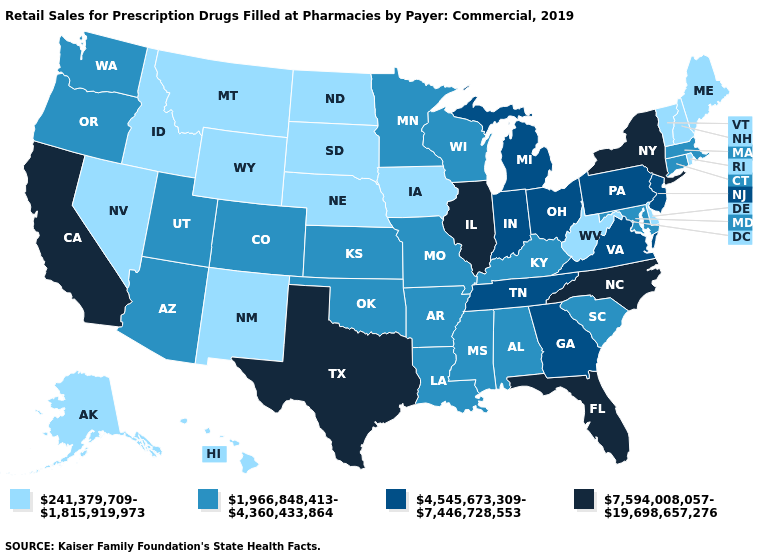Name the states that have a value in the range 4,545,673,309-7,446,728,553?
Keep it brief. Georgia, Indiana, Michigan, New Jersey, Ohio, Pennsylvania, Tennessee, Virginia. Name the states that have a value in the range 241,379,709-1,815,919,973?
Give a very brief answer. Alaska, Delaware, Hawaii, Idaho, Iowa, Maine, Montana, Nebraska, Nevada, New Hampshire, New Mexico, North Dakota, Rhode Island, South Dakota, Vermont, West Virginia, Wyoming. Name the states that have a value in the range 241,379,709-1,815,919,973?
Quick response, please. Alaska, Delaware, Hawaii, Idaho, Iowa, Maine, Montana, Nebraska, Nevada, New Hampshire, New Mexico, North Dakota, Rhode Island, South Dakota, Vermont, West Virginia, Wyoming. Is the legend a continuous bar?
Concise answer only. No. Among the states that border Pennsylvania , which have the lowest value?
Quick response, please. Delaware, West Virginia. Does the map have missing data?
Answer briefly. No. Name the states that have a value in the range 4,545,673,309-7,446,728,553?
Concise answer only. Georgia, Indiana, Michigan, New Jersey, Ohio, Pennsylvania, Tennessee, Virginia. What is the value of Massachusetts?
Answer briefly. 1,966,848,413-4,360,433,864. Which states hav the highest value in the West?
Quick response, please. California. Which states have the lowest value in the West?
Keep it brief. Alaska, Hawaii, Idaho, Montana, Nevada, New Mexico, Wyoming. Name the states that have a value in the range 4,545,673,309-7,446,728,553?
Answer briefly. Georgia, Indiana, Michigan, New Jersey, Ohio, Pennsylvania, Tennessee, Virginia. Which states have the lowest value in the USA?
Write a very short answer. Alaska, Delaware, Hawaii, Idaho, Iowa, Maine, Montana, Nebraska, Nevada, New Hampshire, New Mexico, North Dakota, Rhode Island, South Dakota, Vermont, West Virginia, Wyoming. Does the first symbol in the legend represent the smallest category?
Answer briefly. Yes. Name the states that have a value in the range 7,594,008,057-19,698,657,276?
Quick response, please. California, Florida, Illinois, New York, North Carolina, Texas. What is the highest value in the USA?
Concise answer only. 7,594,008,057-19,698,657,276. 